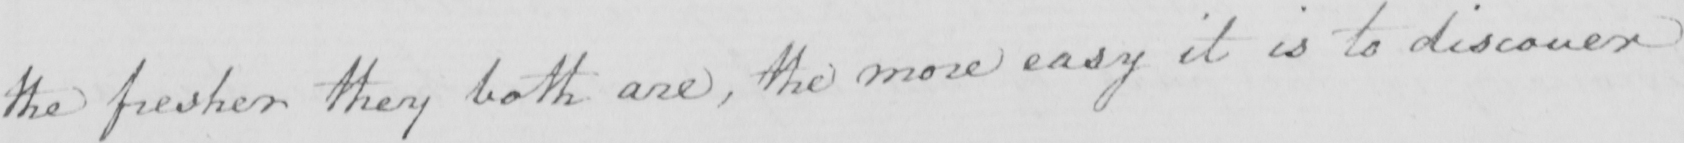What is written in this line of handwriting? the fresher they both are , the more easy it is to discover 